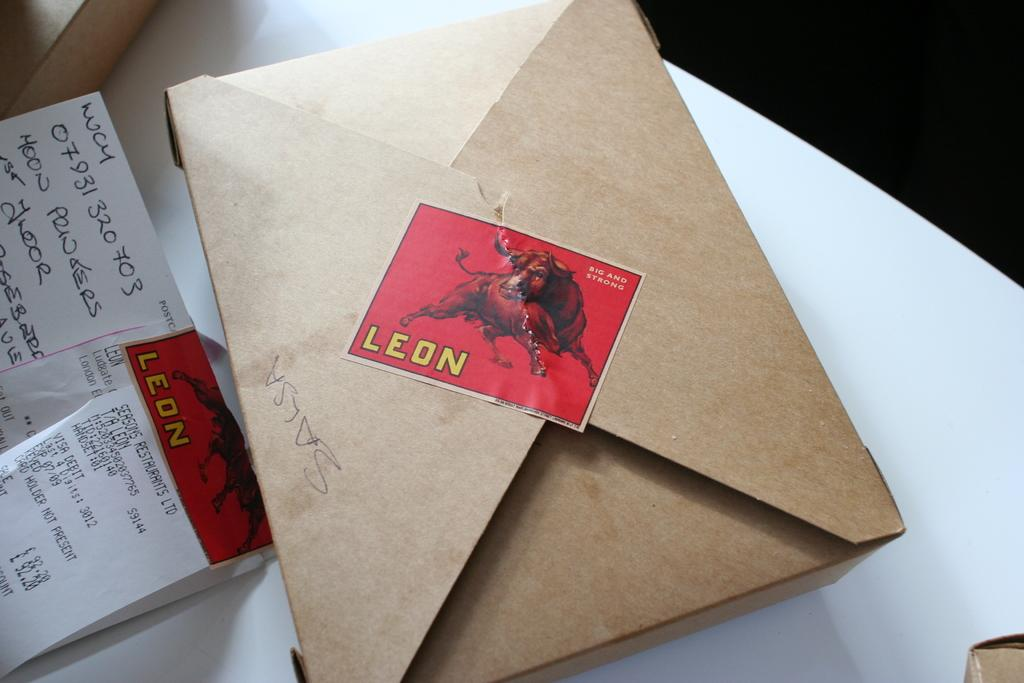Provide a one-sentence caption for the provided image. a brown box is closed with a stamp that says leon. 